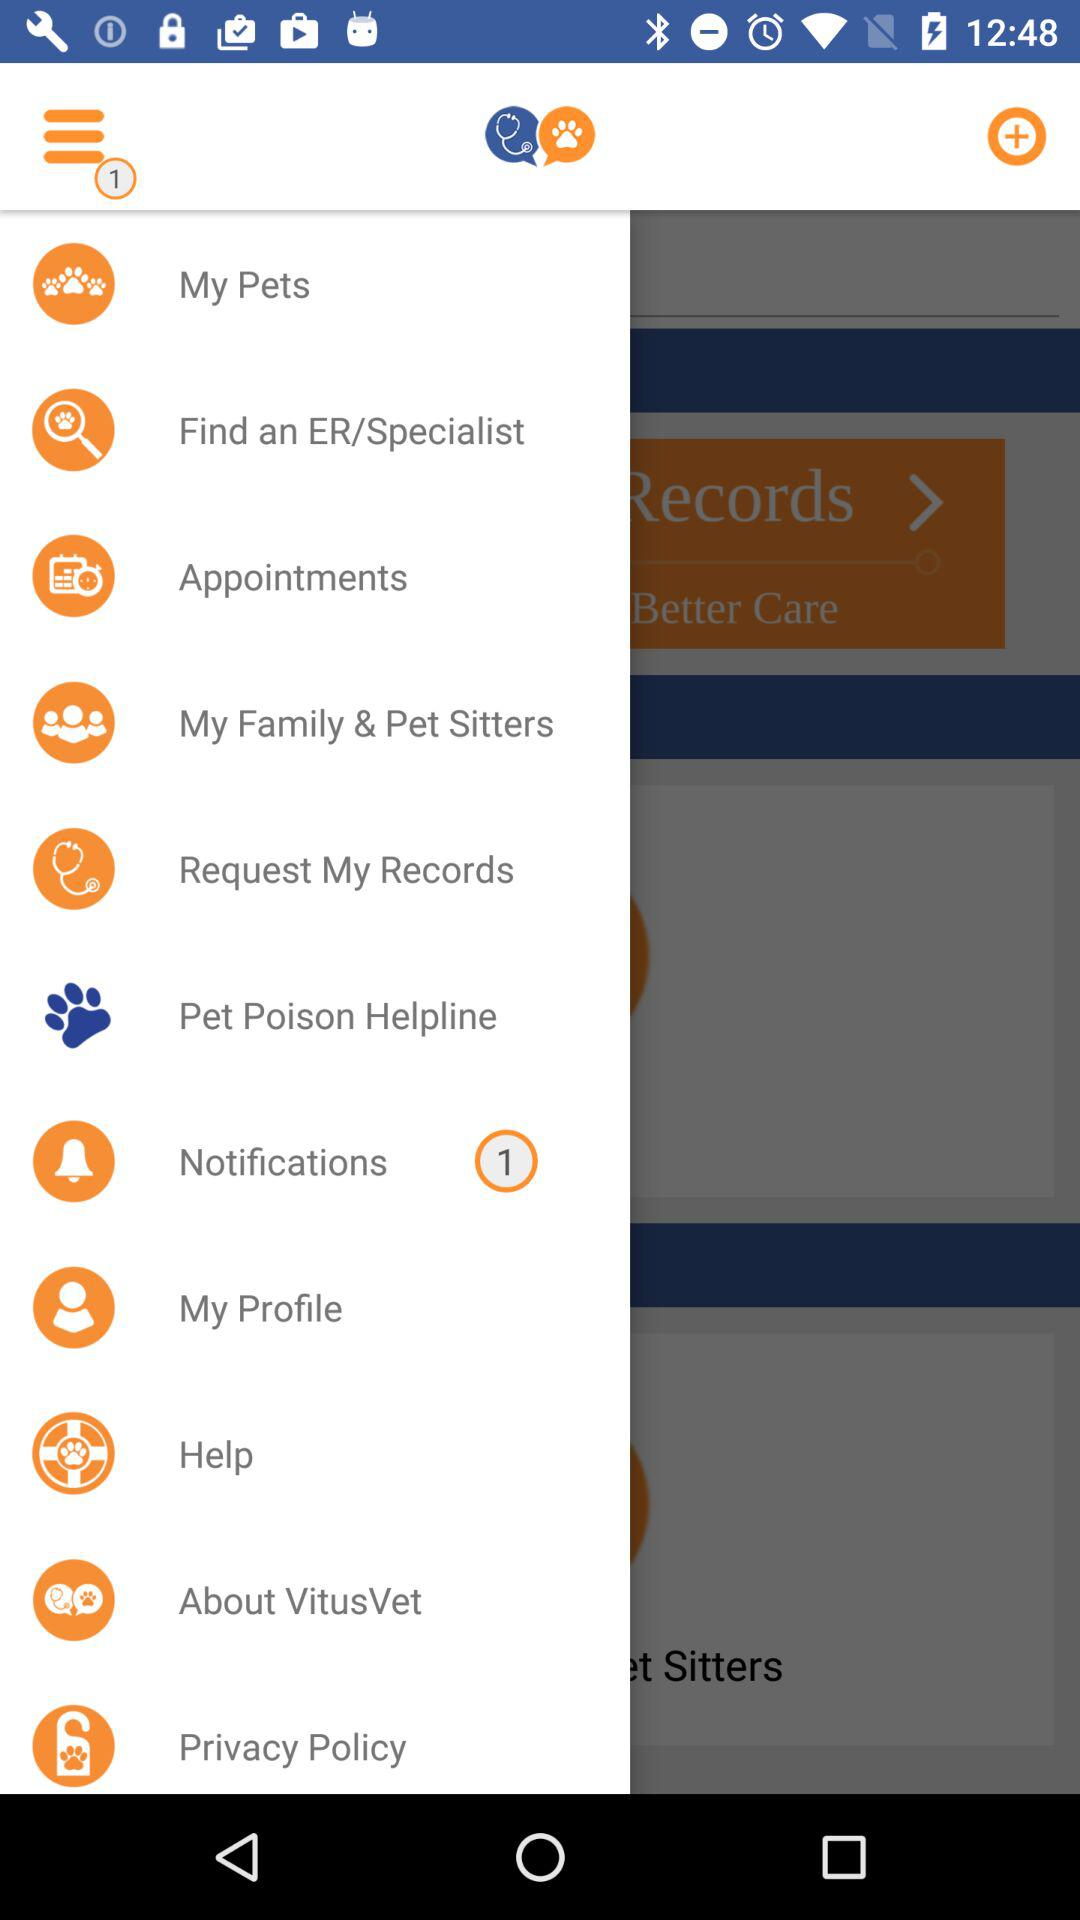How many notifications are there? There is 1 notification. 